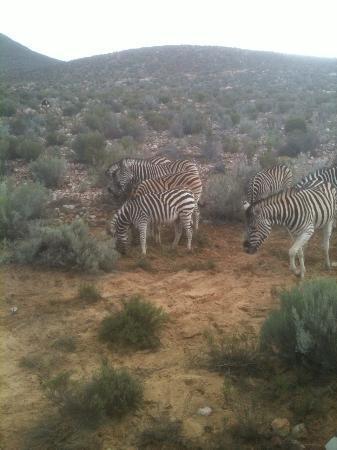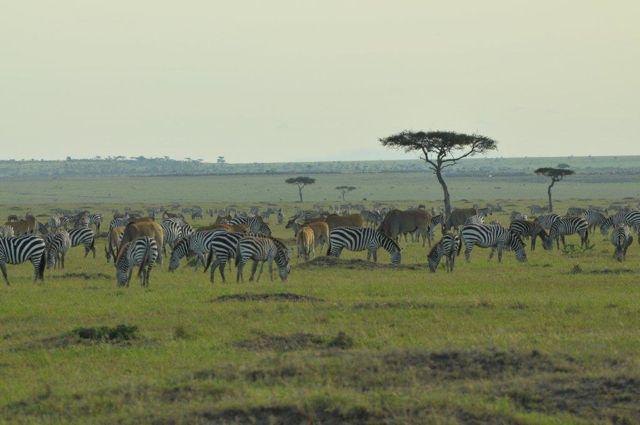The first image is the image on the left, the second image is the image on the right. Examine the images to the left and right. Is the description "There are more than four zebras in each image." accurate? Answer yes or no. Yes. The first image is the image on the left, the second image is the image on the right. For the images displayed, is the sentence "The right image contains no more than five zebras." factually correct? Answer yes or no. No. 